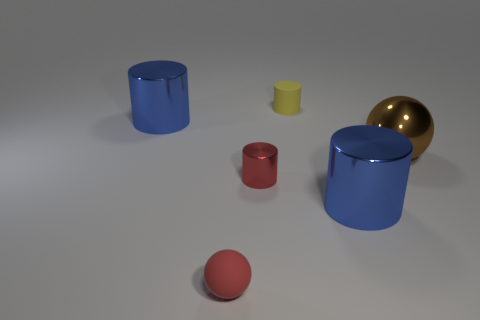There is a matte ball that is the same color as the tiny shiny object; what is its size?
Ensure brevity in your answer.  Small. There is a small object that is both to the left of the yellow cylinder and behind the red matte object; what shape is it?
Your answer should be compact. Cylinder. How many large cylinders are the same color as the small sphere?
Ensure brevity in your answer.  0. What number of other objects are the same size as the brown sphere?
Keep it short and to the point. 2. There is a thing that is behind the brown metallic sphere and in front of the yellow thing; what is its size?
Provide a short and direct response. Large. How many red rubber things are the same shape as the yellow thing?
Your response must be concise. 0. What is the small ball made of?
Your answer should be compact. Rubber. Is the tiny red shiny thing the same shape as the yellow rubber object?
Give a very brief answer. Yes. Is there a tiny yellow thing that has the same material as the big brown sphere?
Offer a very short reply. No. The tiny object that is both in front of the brown ball and behind the tiny sphere is what color?
Make the answer very short. Red. 